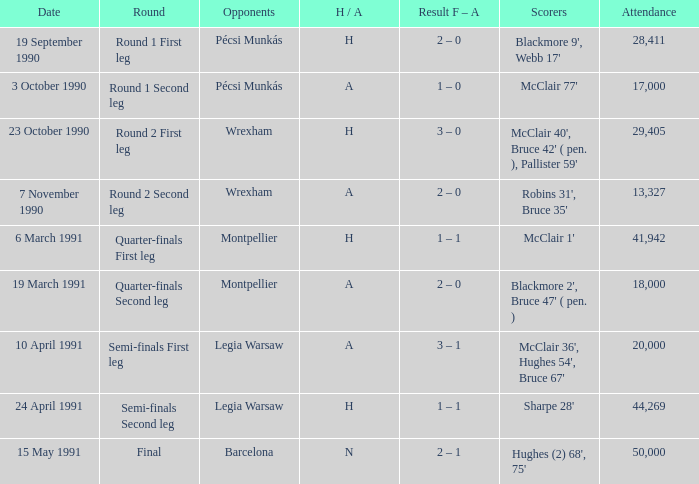What is the rival's name when the h/a is h with a presence of more than 28,411 and sharpe 28' scoring? Legia Warsaw. 